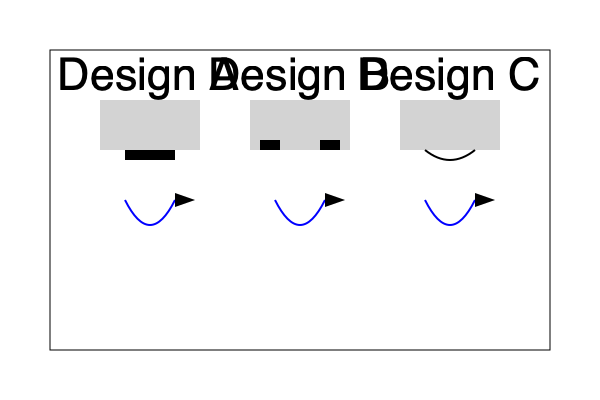Based on the cross-sectional diagrams of three different hive entrance designs (A, B, and C) shown above, which design would likely provide the most efficient ventilation and bee traffic flow? Explain your reasoning, considering factors such as air circulation, ease of bee movement, and potential for congestion. To determine the most efficient hive entrance design for ventilation and bee traffic flow, we need to analyze each design:

1. Design A:
   - Single, wide entrance at the bottom
   - Pros: Allows for easy bee traffic flow, simple design
   - Cons: Limited control over ventilation, potential for drafts

2. Design B:
   - Two smaller entrances at the bottom
   - Pros: Provides better control over ventilation, allows for separate entrance and exit
   - Cons: Potentially more congestion due to smaller openings

3. Design C:
   - Curved, bottom entrance
   - Pros: Improved air circulation due to curved design, natural protection against drafts
   - Cons: Slightly more complex for bees to navigate

Analyzing the factors:

1. Air circulation:
   Design C provides the best air circulation due to its curved shape, which creates a natural airflow pattern. This helps in maintaining optimal temperature and humidity levels inside the hive.

2. Ease of bee movement:
   Design A offers the easiest movement for bees due to its wide, simple entrance. However, Design C's curved entrance still allows for relatively easy movement while providing additional benefits.

3. Potential for congestion:
   Design B has the highest potential for congestion due to its two smaller entrances. Design A and C both offer sufficient space for bee traffic.

4. Protection against external factors:
   Design C provides better protection against wind, rain, and pests due to its curved shape, which acts as a partial barrier.

5. Ventilation control:
   Design B offers the best control over ventilation, as one entrance can be partially or fully closed if needed. However, Design C provides a good balance between ventilation and protection.

Considering all these factors, Design C appears to be the most efficient option. It offers improved air circulation, decent ease of movement for bees, low congestion potential, and better protection against external factors. The curved design promotes natural airflow, which is beneficial for both ventilation and temperature regulation within the hive.
Answer: Design C, due to its curved shape promoting natural airflow and balancing ventilation, bee movement, and protection. 